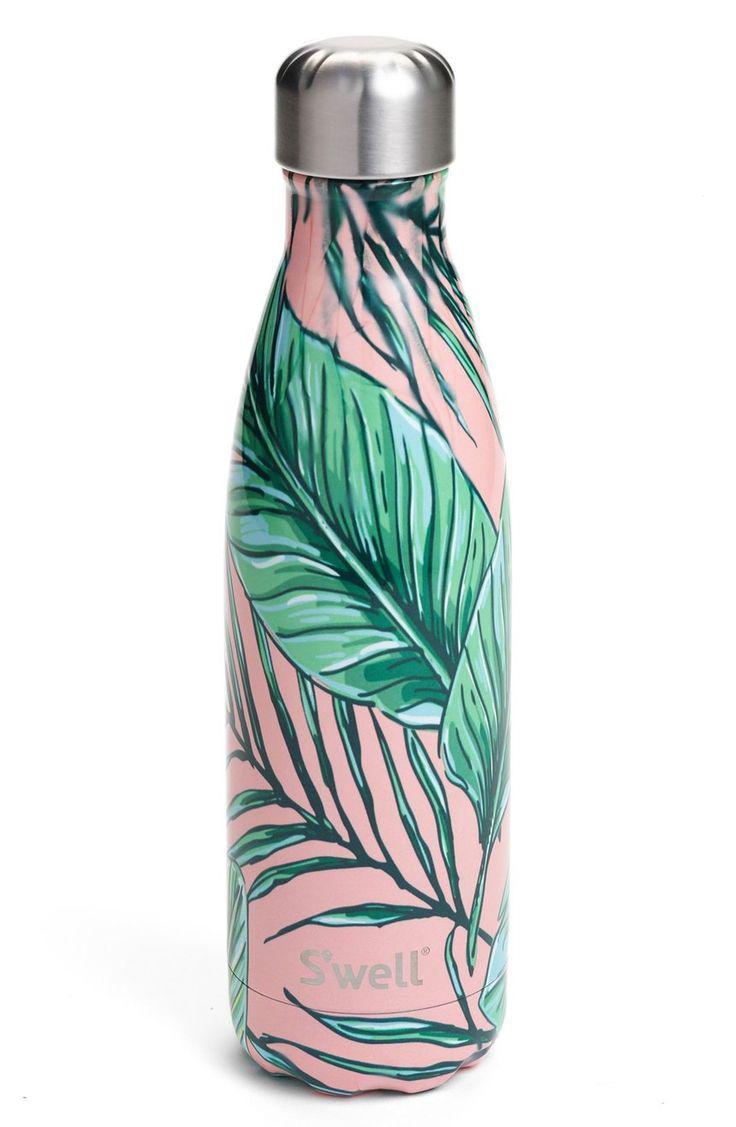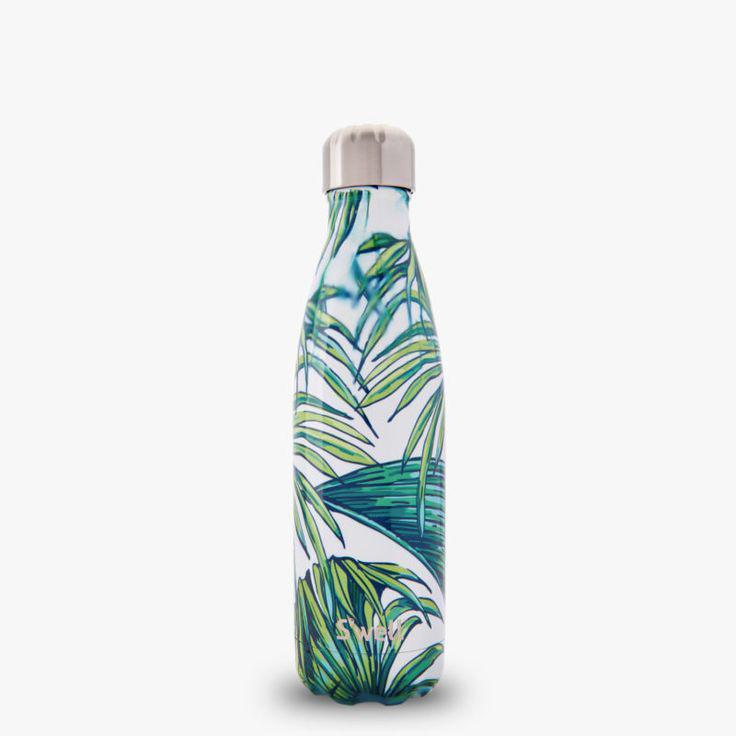The first image is the image on the left, the second image is the image on the right. Given the left and right images, does the statement "There are stainless steel water bottles that are all solid colored." hold true? Answer yes or no. No. 